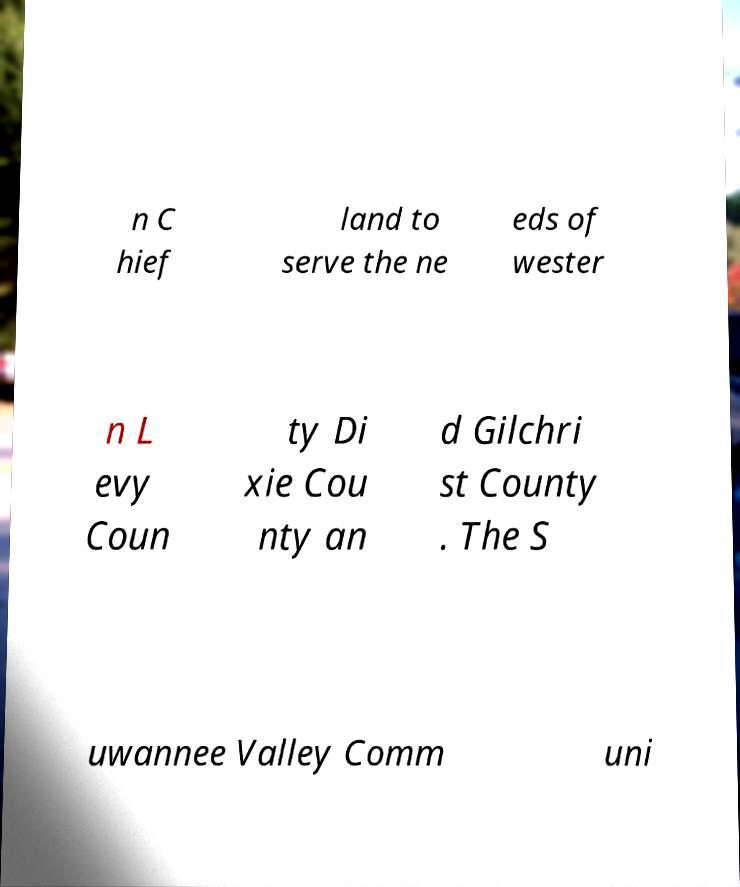Please identify and transcribe the text found in this image. n C hief land to serve the ne eds of wester n L evy Coun ty Di xie Cou nty an d Gilchri st County . The S uwannee Valley Comm uni 